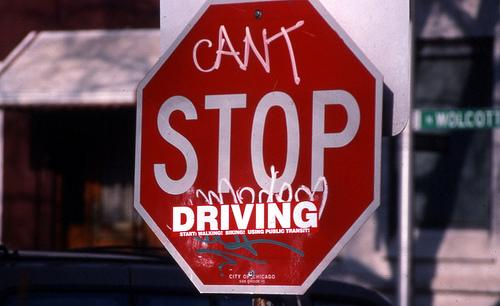Briefly mention the main focus of the image and its characteristics. There is a vandalized octagonal stop sign with white graffiti, white border, and attached to a metal pole. Write a brief sentence that highlights the main subject of the image. A graffiti-laden red stop sign with a white border affixed to a pole is the centerpiece of the image. Describe the primary focus of the image in a succinct sentence. A red, octagonal stop sign with white graffiti and a white border stands out on its pole in the image. Describe the image's primary subject in a short sentence. A red stop sign with white graffiti and white edging is affixed to a pole in front of a green street sign. Provide a brief description of the most noticeable element in the image. The image prominently features a red octagonal stop sign with white graffiti and a white border. Create a sentence that encapsulates the central object in the image. A vandalized red stop sign with a white border and graffiti is attached to a metal pole. Write a concise sentence summarizing the most important aspect of the image. The image showcases an octagonal red stop sign defaced with white graffiti, mounted on a metal pole. Summarize the main object in the image in one sentence. An octagonal red stop sign with a white edge and graffiti occupies the space atop a metal pole. In a single sentence, describe the primary object in the image and its key features. A red and white graffiti-marked stop sign is fastened to a metal pole and shares space with a green street sign. Provide a short description of what the image mainly represents. A red, graffiti-covered stop sign with a white border is mounted on a pole, alongside a green street sign. 